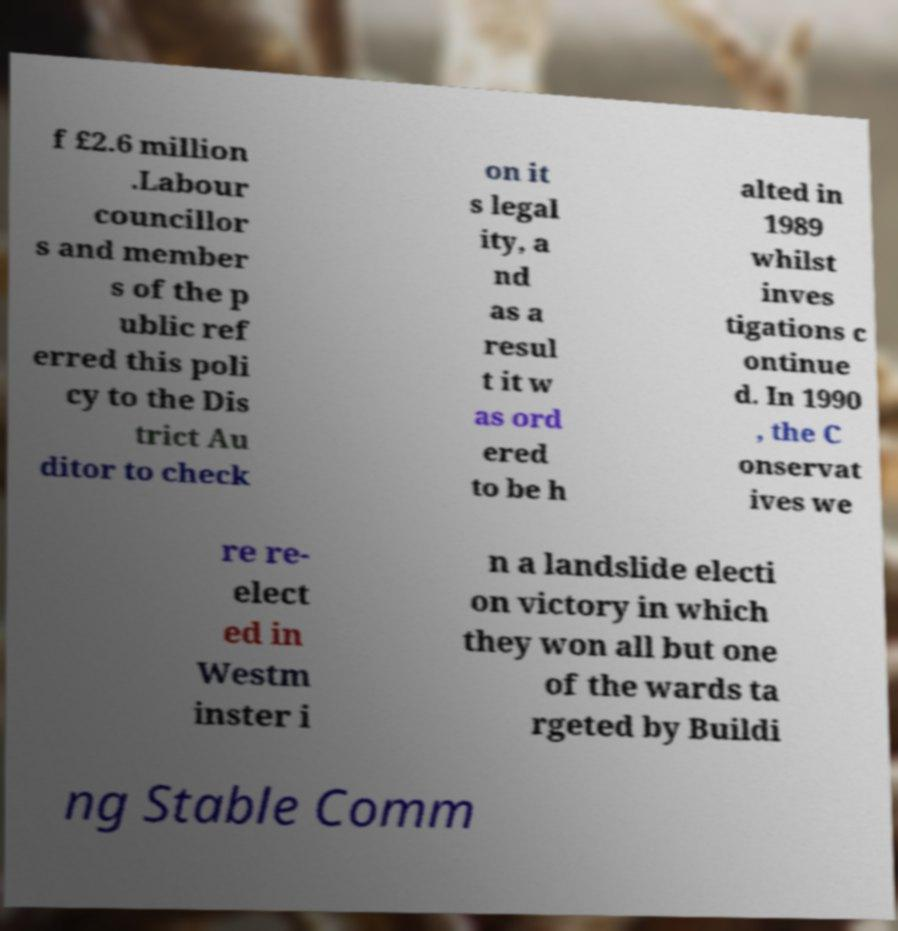I need the written content from this picture converted into text. Can you do that? f £2.6 million .Labour councillor s and member s of the p ublic ref erred this poli cy to the Dis trict Au ditor to check on it s legal ity, a nd as a resul t it w as ord ered to be h alted in 1989 whilst inves tigations c ontinue d. In 1990 , the C onservat ives we re re- elect ed in Westm inster i n a landslide electi on victory in which they won all but one of the wards ta rgeted by Buildi ng Stable Comm 